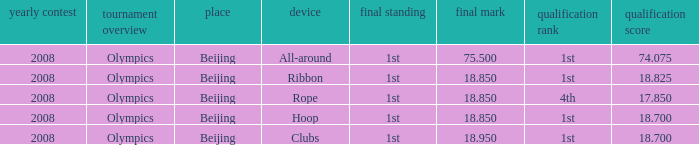What was her final score on the ribbon apparatus? 18.85. 